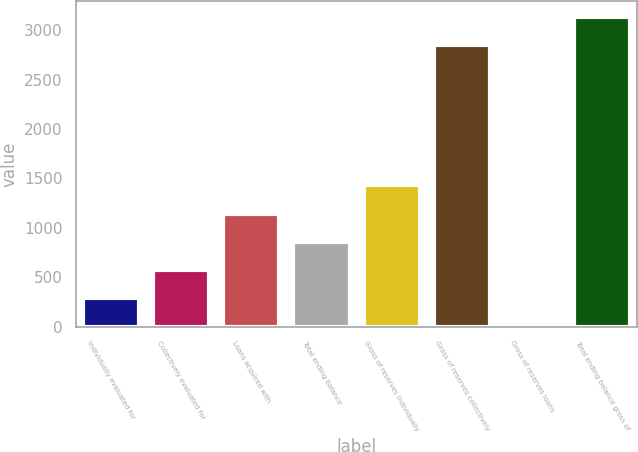Convert chart to OTSL. <chart><loc_0><loc_0><loc_500><loc_500><bar_chart><fcel>Individually evaluated for<fcel>Collectively evaluated for<fcel>Loans acquired with<fcel>Total ending balance<fcel>Gross of reserves individually<fcel>Gross of reserves collectively<fcel>Gross of reserves loans<fcel>Total ending balance gross of<nl><fcel>286.25<fcel>572.11<fcel>1143.83<fcel>857.97<fcel>1429.69<fcel>2851<fcel>0.39<fcel>3136.86<nl></chart> 